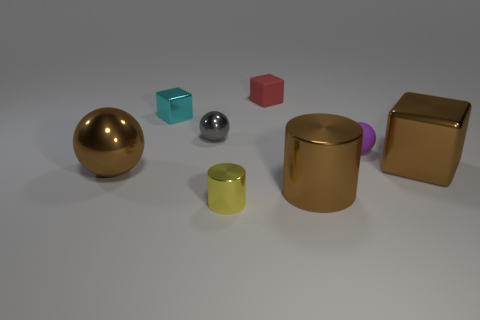Comparing textures, which object stands out the most? The red cube stands out due to its matte finish, which contrasts with the other objects that possess metallic and reflective textures. Its lack of glossiness and distinct color make it visually unique among the collection. 